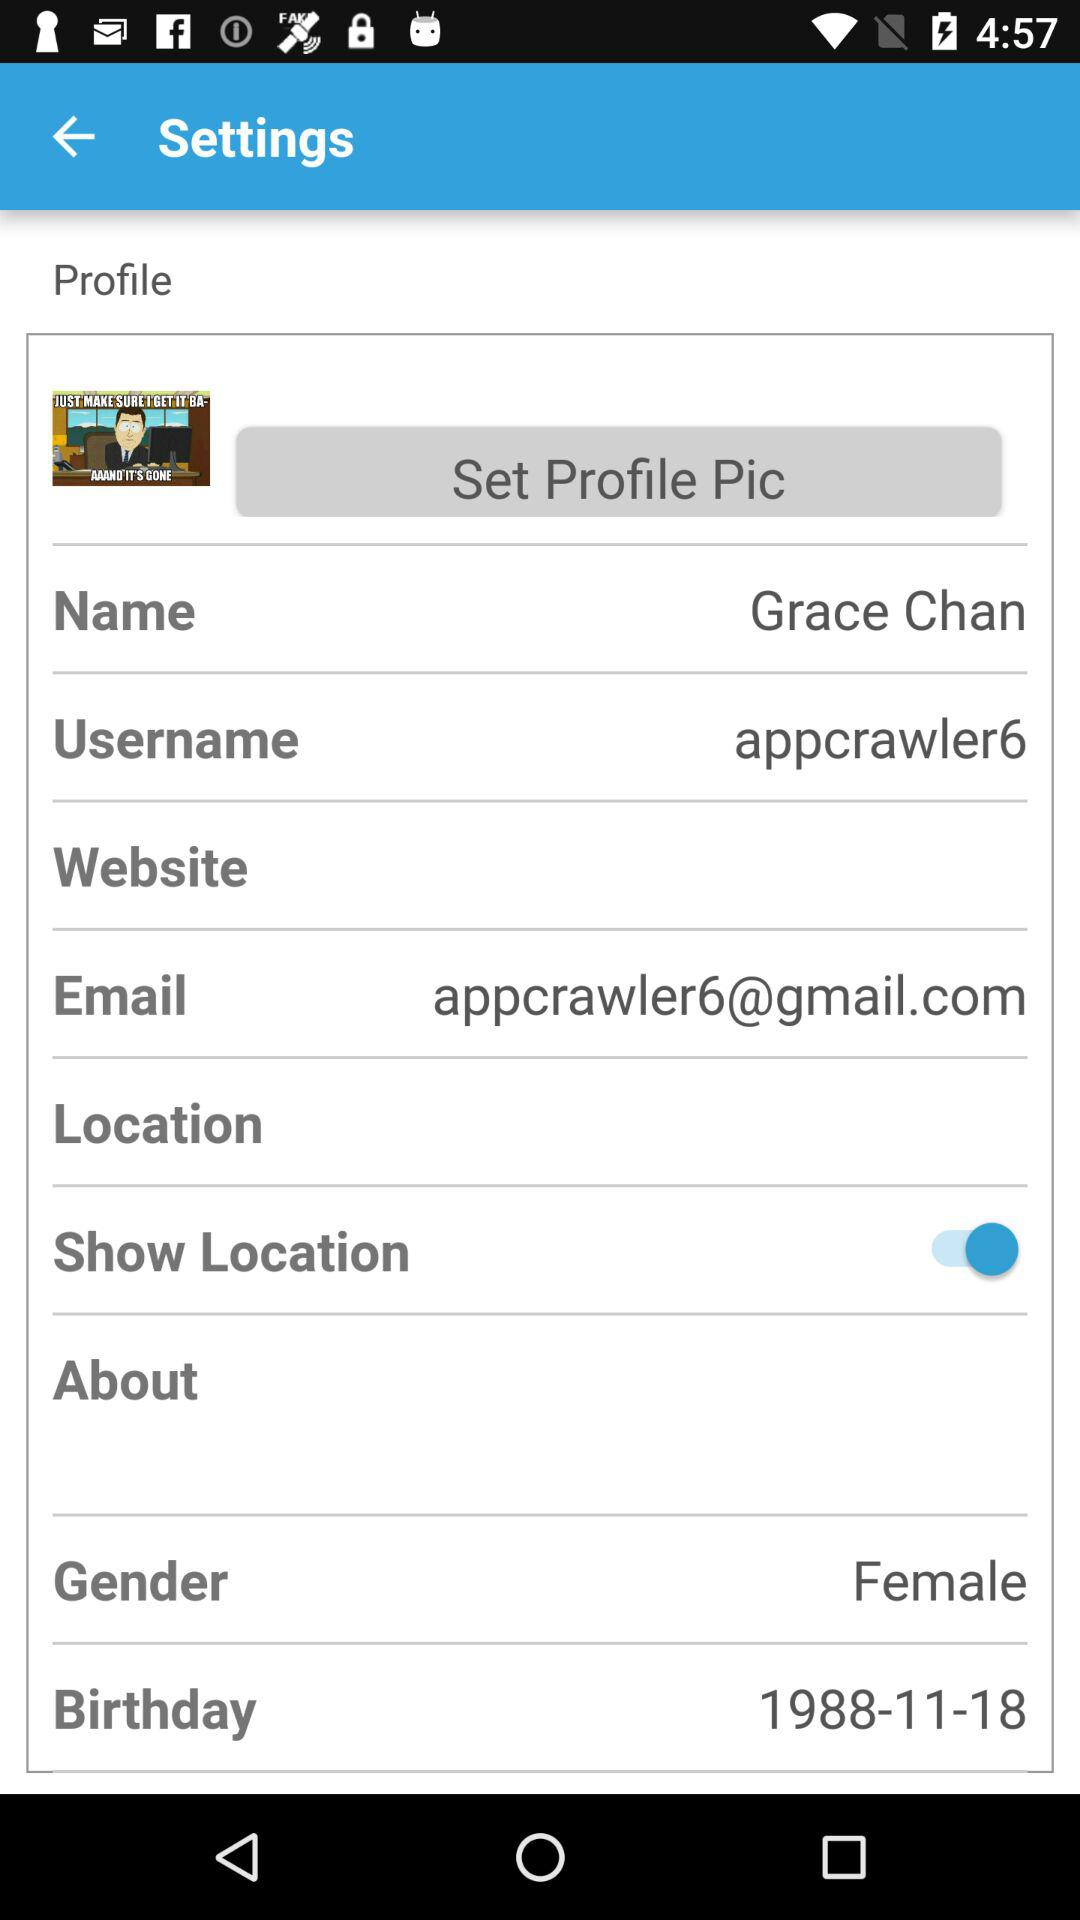What is the user name? The user name is appcrawler6. 